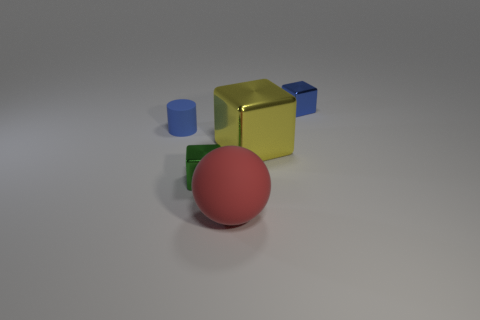Subtract all tiny metal blocks. How many blocks are left? 1 Subtract 3 cubes. How many cubes are left? 0 Add 3 red things. How many objects exist? 8 Subtract all blue cubes. How many cubes are left? 2 Subtract all spheres. How many objects are left? 4 Subtract all big green cubes. Subtract all small metal blocks. How many objects are left? 3 Add 2 tiny blue matte objects. How many tiny blue matte objects are left? 3 Add 1 purple metal balls. How many purple metal balls exist? 1 Subtract 1 red spheres. How many objects are left? 4 Subtract all brown cubes. Subtract all yellow spheres. How many cubes are left? 3 